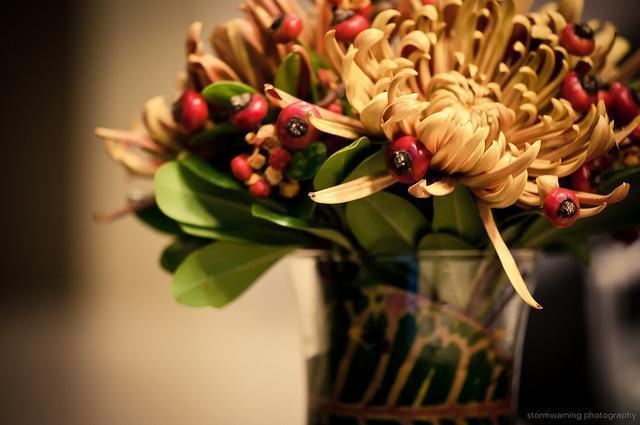How many bears are in the water?
Give a very brief answer. 0. 